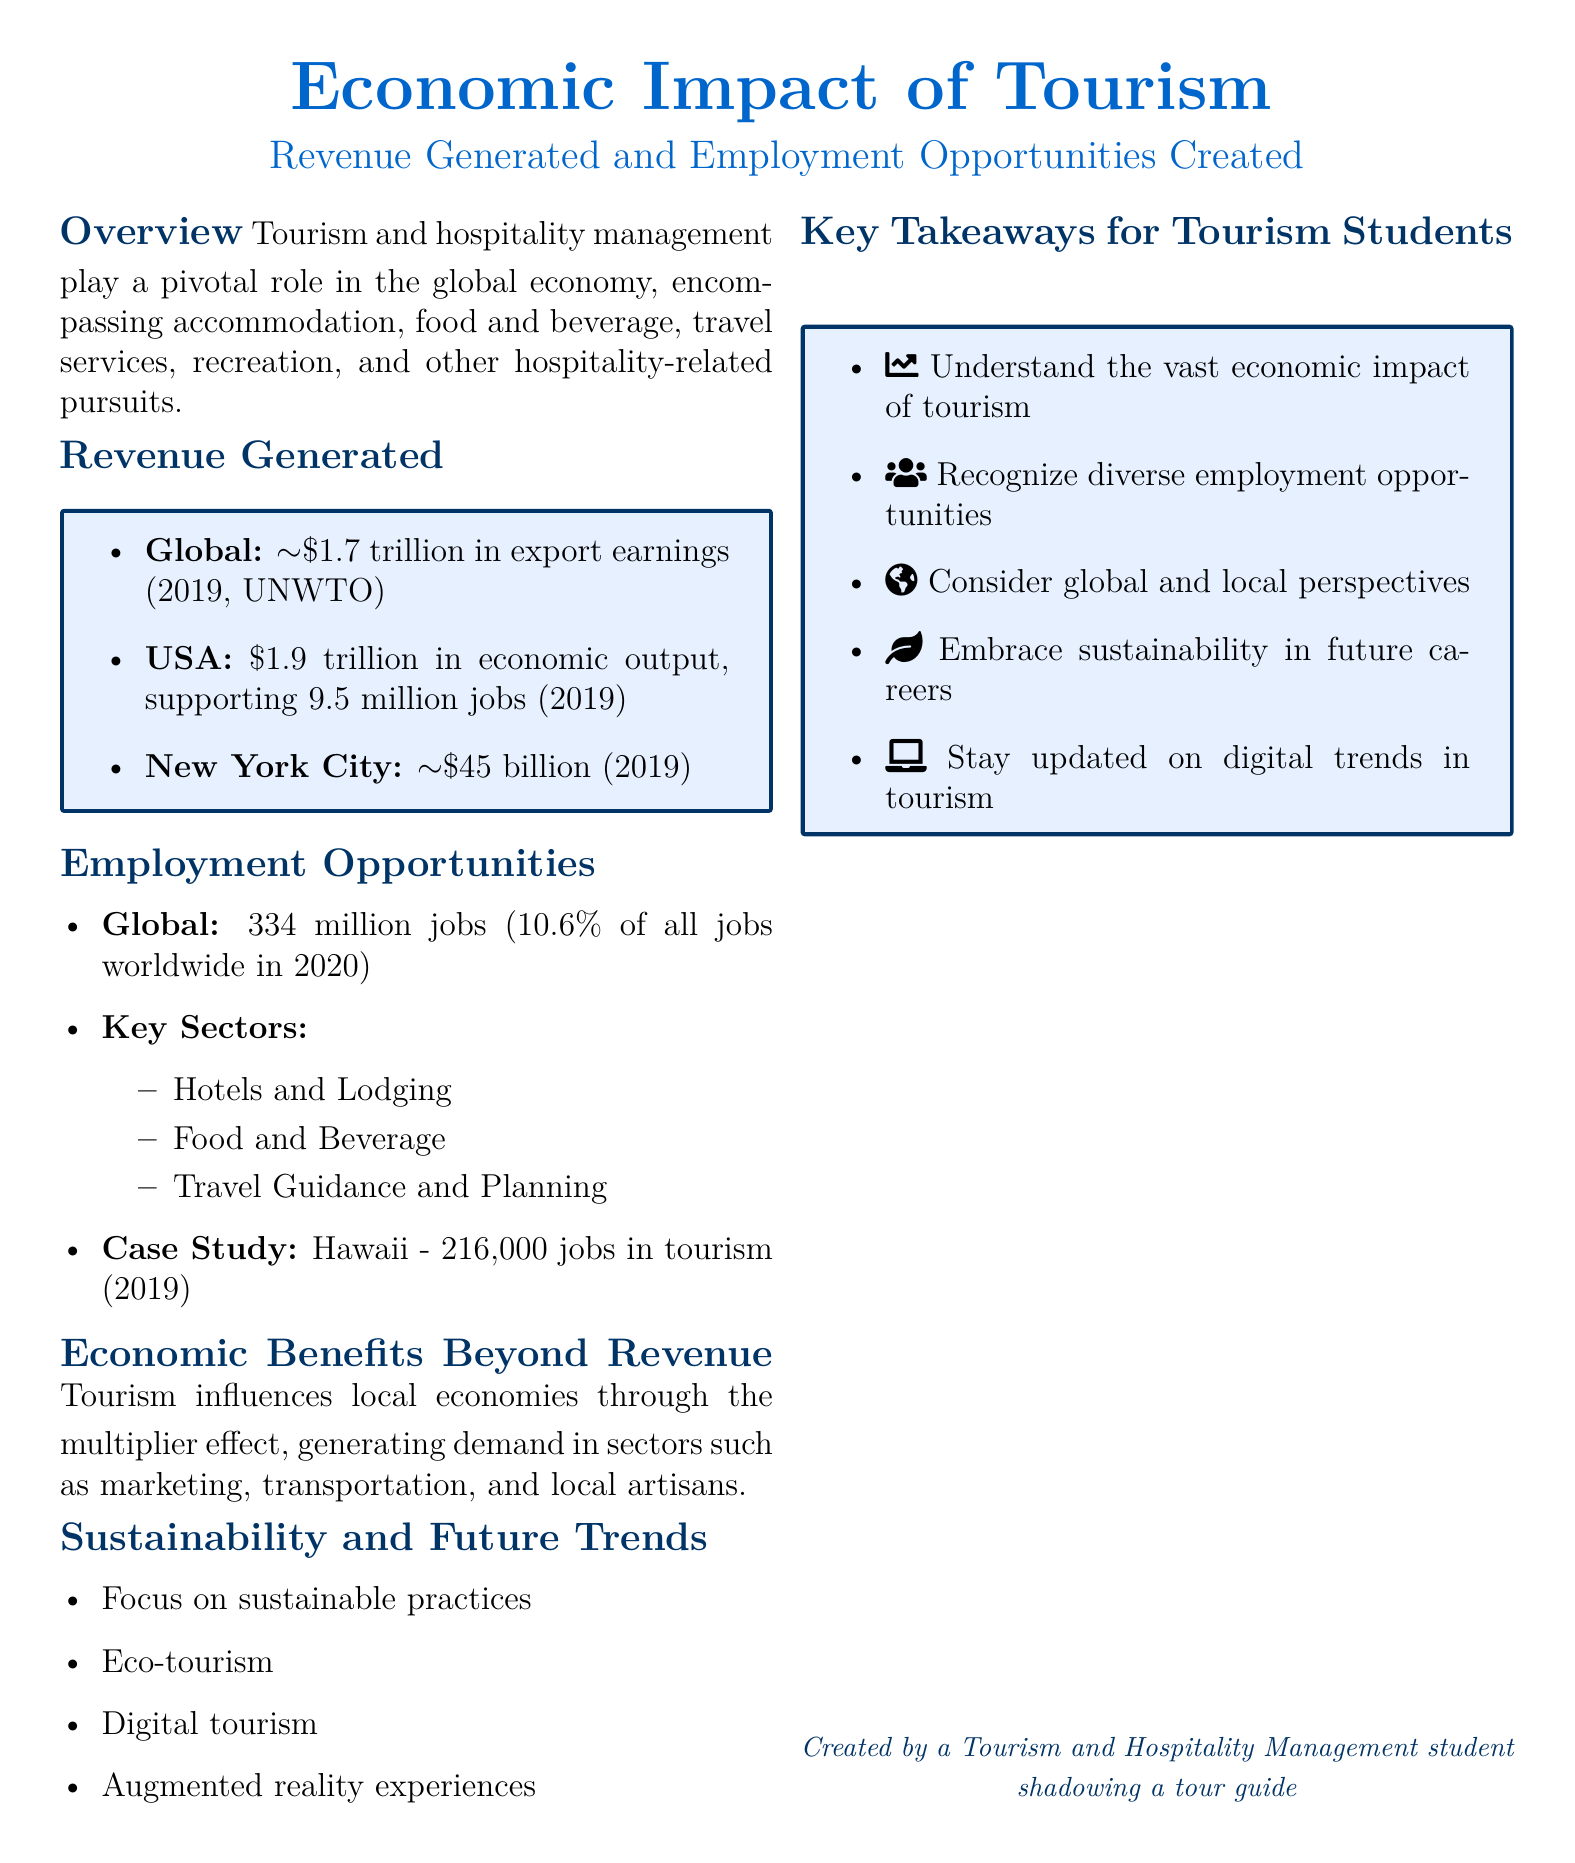What was the global export earnings from tourism in 2019? The document states that global export earnings from tourism were approximately $1.7 trillion in 2019.
Answer: $1.7 trillion How many jobs did tourism support in the USA in 2019? According to the document, tourism supported 9.5 million jobs in the USA in 2019.
Answer: 9.5 million What percentage of all jobs worldwide did tourism account for in 2020? The document mentions that tourism accounted for 10.6% of all jobs worldwide in 2020.
Answer: 10.6% Which case study location had 216,000 jobs in tourism? The document provides a case study indicating that Hawaii had 216,000 jobs in tourism.
Answer: Hawaii What key sector is NOT listed in the employment opportunities? The document specifically lists several key sectors, and "Transportation" is not among them.
Answer: Transportation How much did New York City generate in tourism revenue in 2019? The document states that New York City generated approximately $45 billion in tourism revenue in 2019.
Answer: $45 billion What is one of the future trends mentioned in the document? The document lists future trends including digital tourism, indicating a focus on modern technological approaches.
Answer: Digital tourism What concept explains the economic benefits beyond direct revenue? The document refers to the "multiplier effect" as a concept that influences local economies beyond direct revenue.
Answer: Multiplier effect What is a suggested focus for tourism students according to the key takeaways? The document suggests that tourism students should embrace sustainability in their future careers.
Answer: Sustainability 